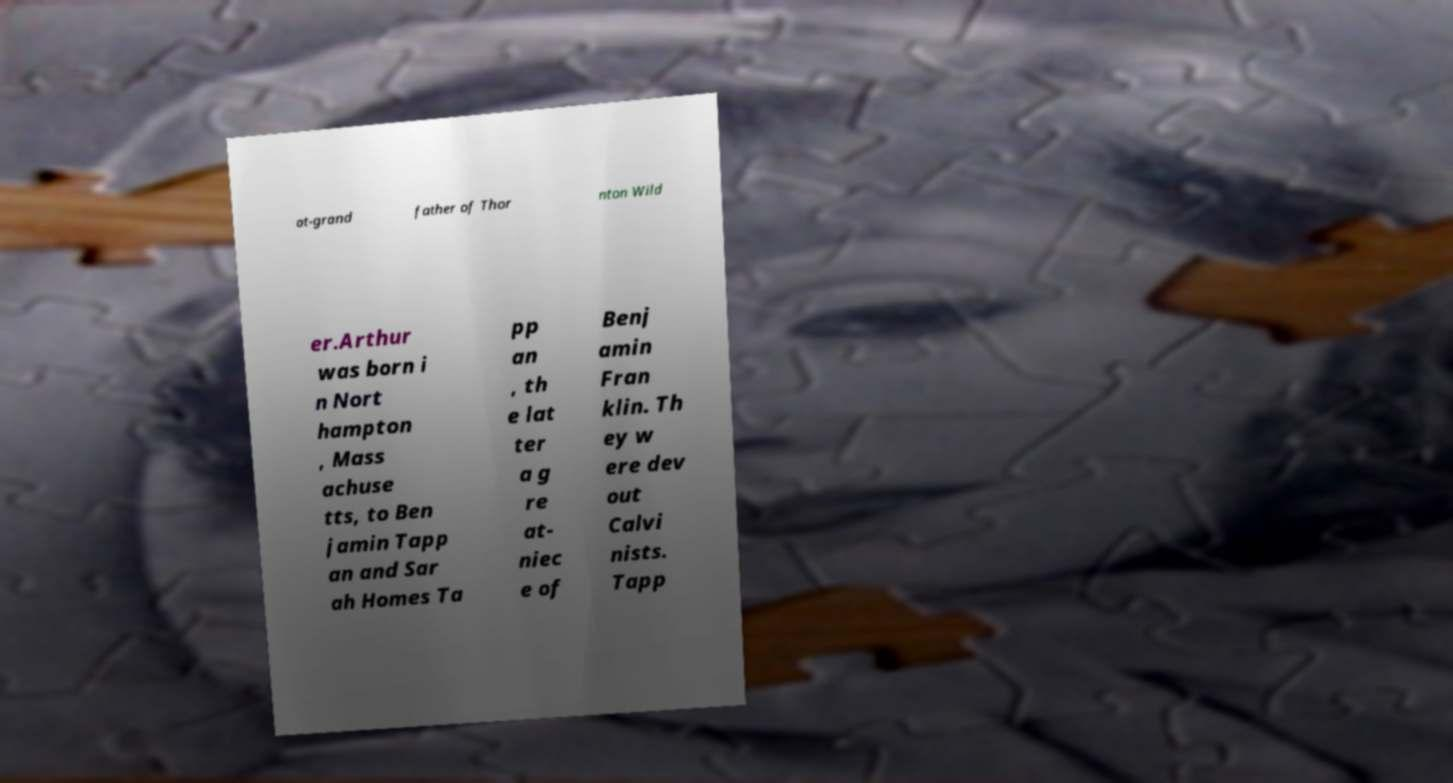Can you read and provide the text displayed in the image?This photo seems to have some interesting text. Can you extract and type it out for me? at-grand father of Thor nton Wild er.Arthur was born i n Nort hampton , Mass achuse tts, to Ben jamin Tapp an and Sar ah Homes Ta pp an , th e lat ter a g re at- niec e of Benj amin Fran klin. Th ey w ere dev out Calvi nists. Tapp 